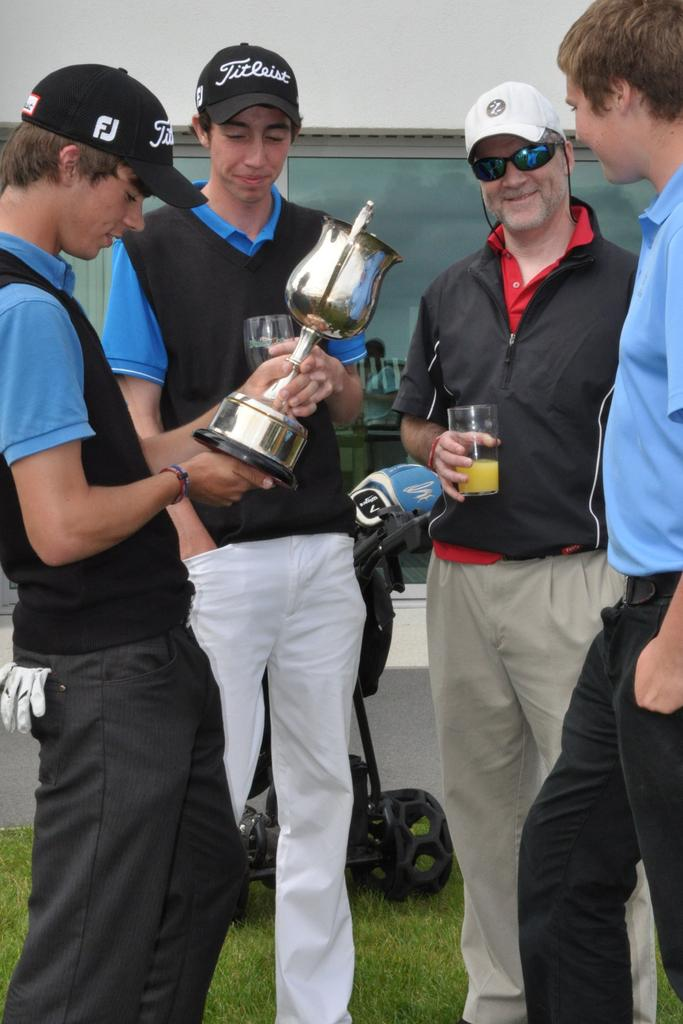<image>
Provide a brief description of the given image. A man in a Titleist hatlooks at a trophy being held by the person next to him. 